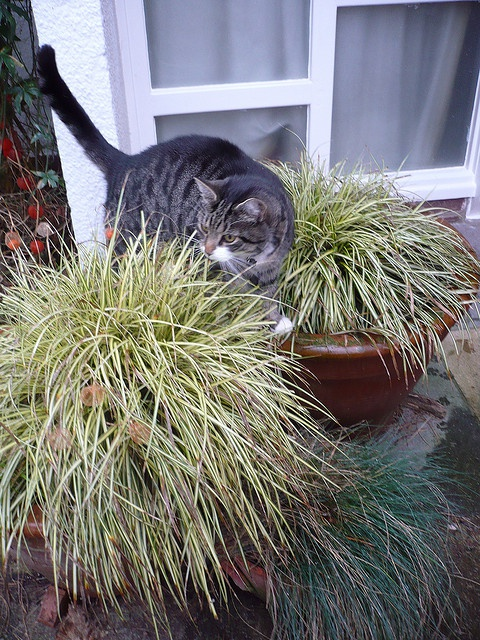Describe the objects in this image and their specific colors. I can see potted plant in black, olive, gray, and darkgray tones, potted plant in black, darkgray, gray, and lightgray tones, potted plant in black, gray, teal, and darkgray tones, and cat in black, gray, and darkgray tones in this image. 